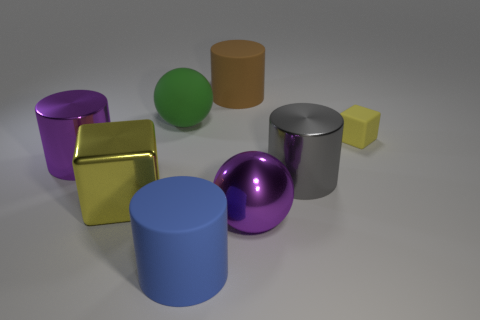What number of big blue things are made of the same material as the small object?
Make the answer very short. 1. How many large matte spheres are there?
Give a very brief answer. 1. There is a big rubber cylinder that is right of the blue thing; is it the same color as the big cylinder on the left side of the blue matte thing?
Your answer should be very brief. No. How many rubber cylinders are behind the big blue cylinder?
Your answer should be compact. 1. There is another object that is the same color as the tiny matte object; what material is it?
Offer a terse response. Metal. Are there any other large shiny things of the same shape as the gray metallic thing?
Provide a succinct answer. Yes. Is the sphere that is behind the yellow metal thing made of the same material as the big purple object behind the metallic cube?
Your answer should be compact. No. What is the size of the metal cylinder that is left of the purple shiny thing on the right side of the big cylinder that is behind the small matte cube?
Your answer should be very brief. Large. There is a yellow block that is the same size as the gray metallic cylinder; what is its material?
Offer a terse response. Metal. Is there a brown metallic object that has the same size as the brown rubber cylinder?
Your answer should be compact. No. 